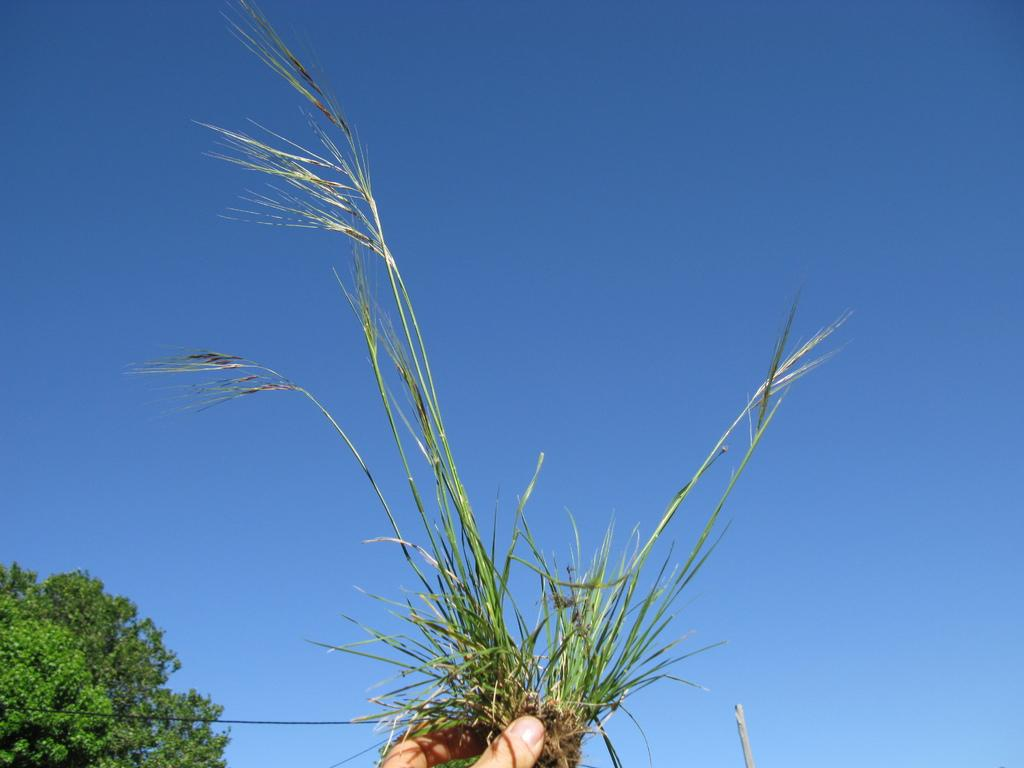What is the person's finger holding in the image? The person's finger is holding grass in the image. What can be seen in the left side bottom corner of the image? There is a tree and wire in the left side bottom corner of the image. What is visible in the background of the image? The sky is visible in the background of the image. How many rings are visible on the person's finger in the image? There is no mention of rings in the image, so we cannot determine the number of rings visible. 